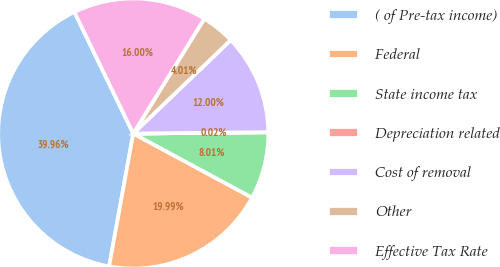Convert chart to OTSL. <chart><loc_0><loc_0><loc_500><loc_500><pie_chart><fcel>( of Pre-tax income)<fcel>Federal<fcel>State income tax<fcel>Depreciation related<fcel>Cost of removal<fcel>Other<fcel>Effective Tax Rate<nl><fcel>39.96%<fcel>19.99%<fcel>8.01%<fcel>0.02%<fcel>12.0%<fcel>4.01%<fcel>16.0%<nl></chart> 